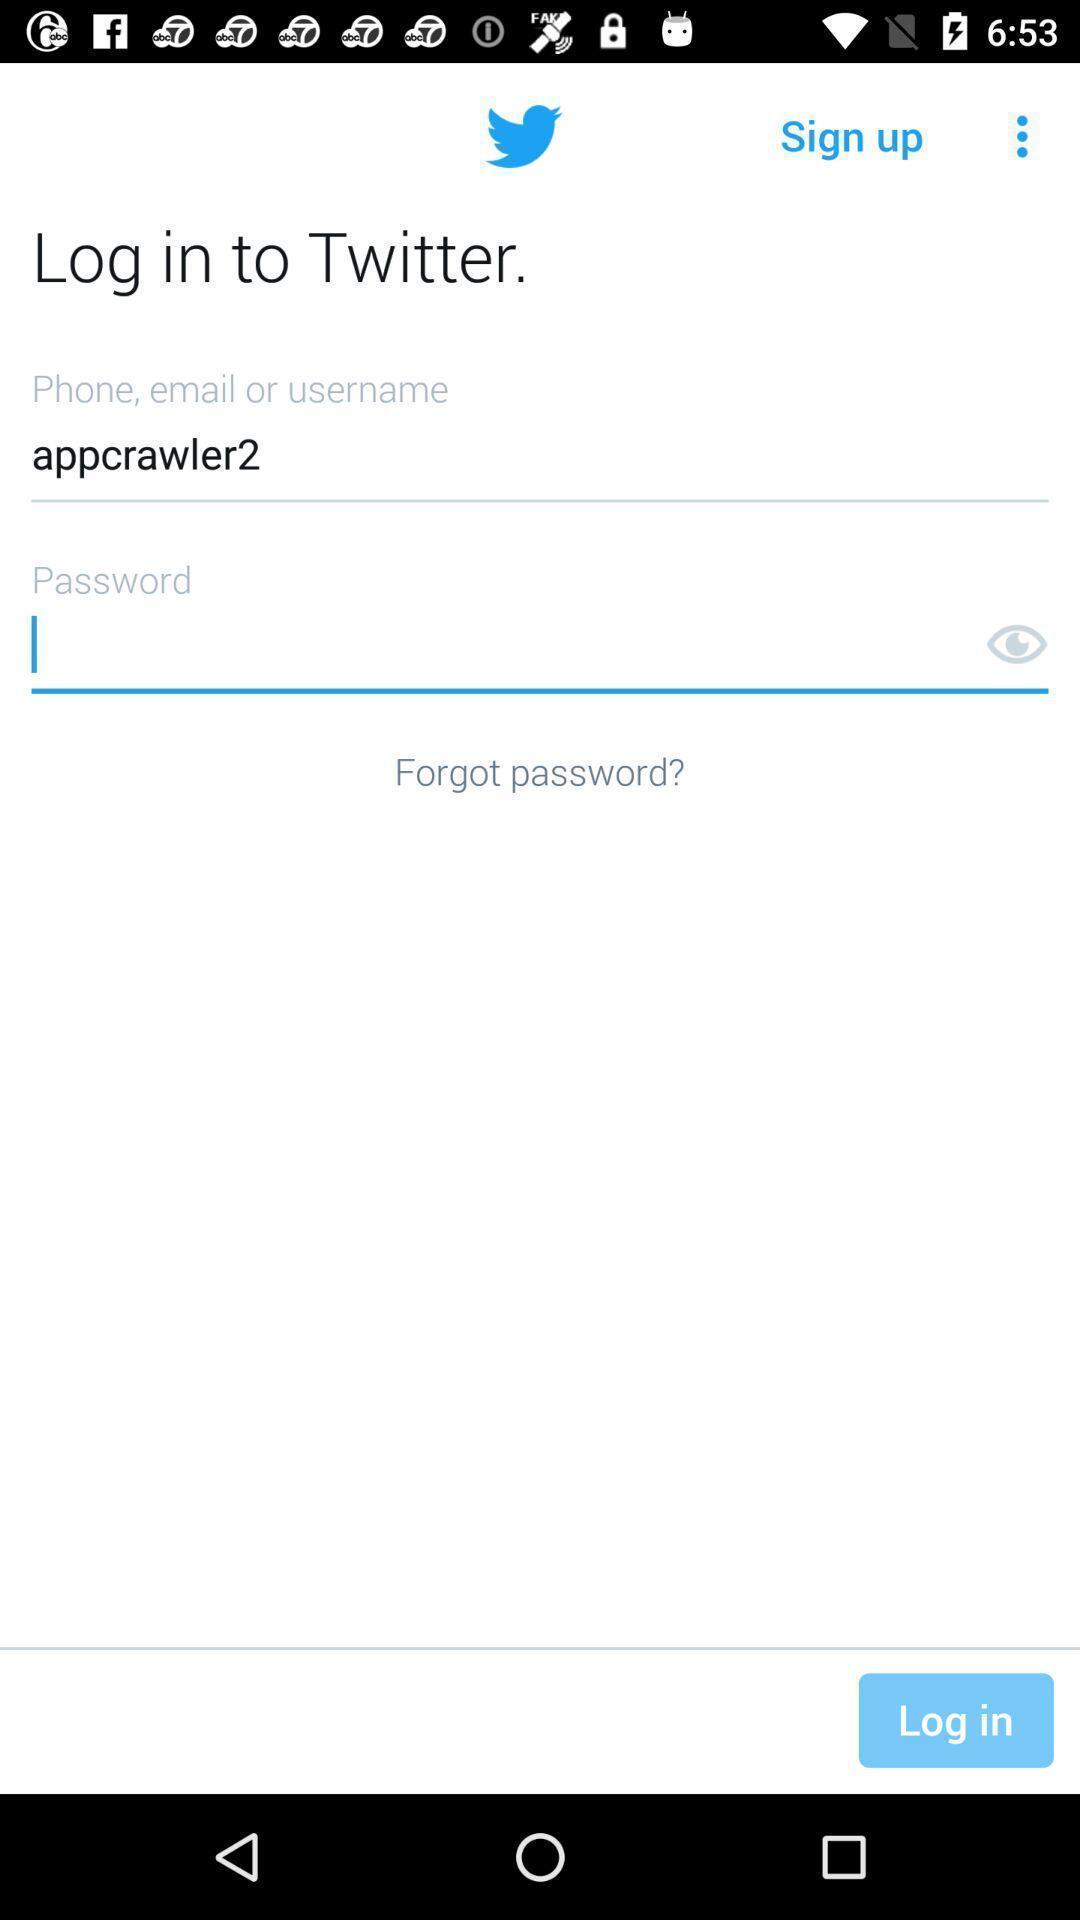Summarize the main components in this picture. Screen displaying the login page. 